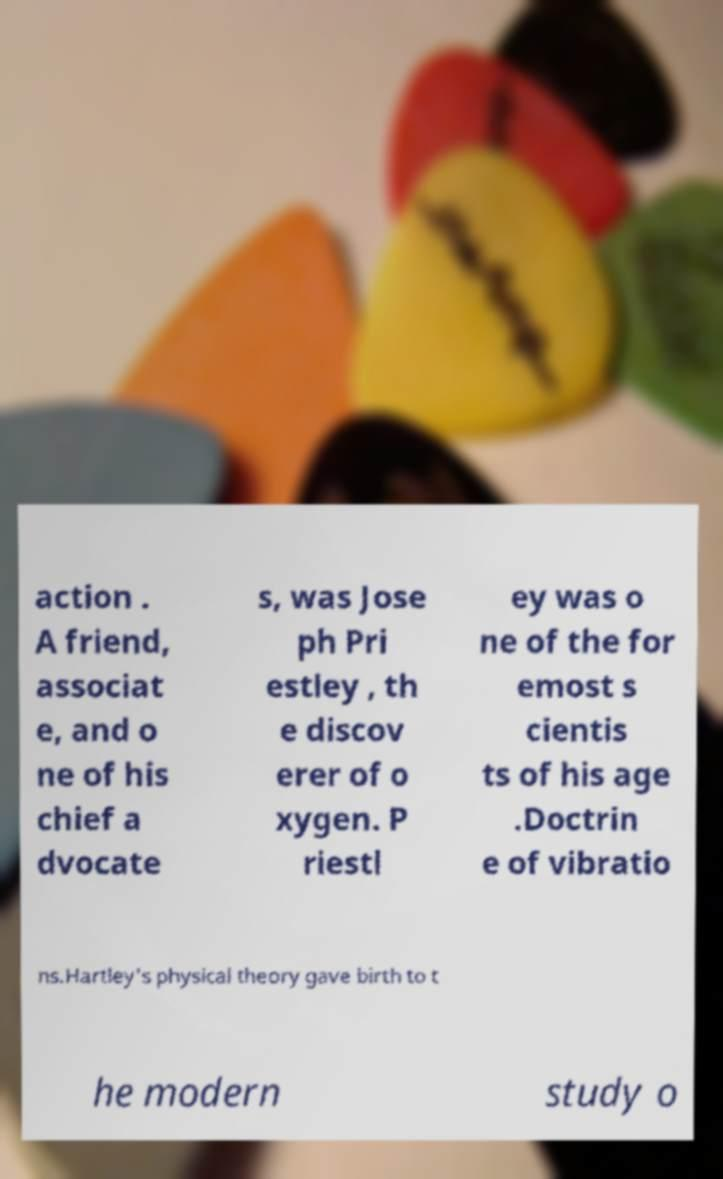Can you accurately transcribe the text from the provided image for me? action . A friend, associat e, and o ne of his chief a dvocate s, was Jose ph Pri estley , th e discov erer of o xygen. P riestl ey was o ne of the for emost s cientis ts of his age .Doctrin e of vibratio ns.Hartley's physical theory gave birth to t he modern study o 